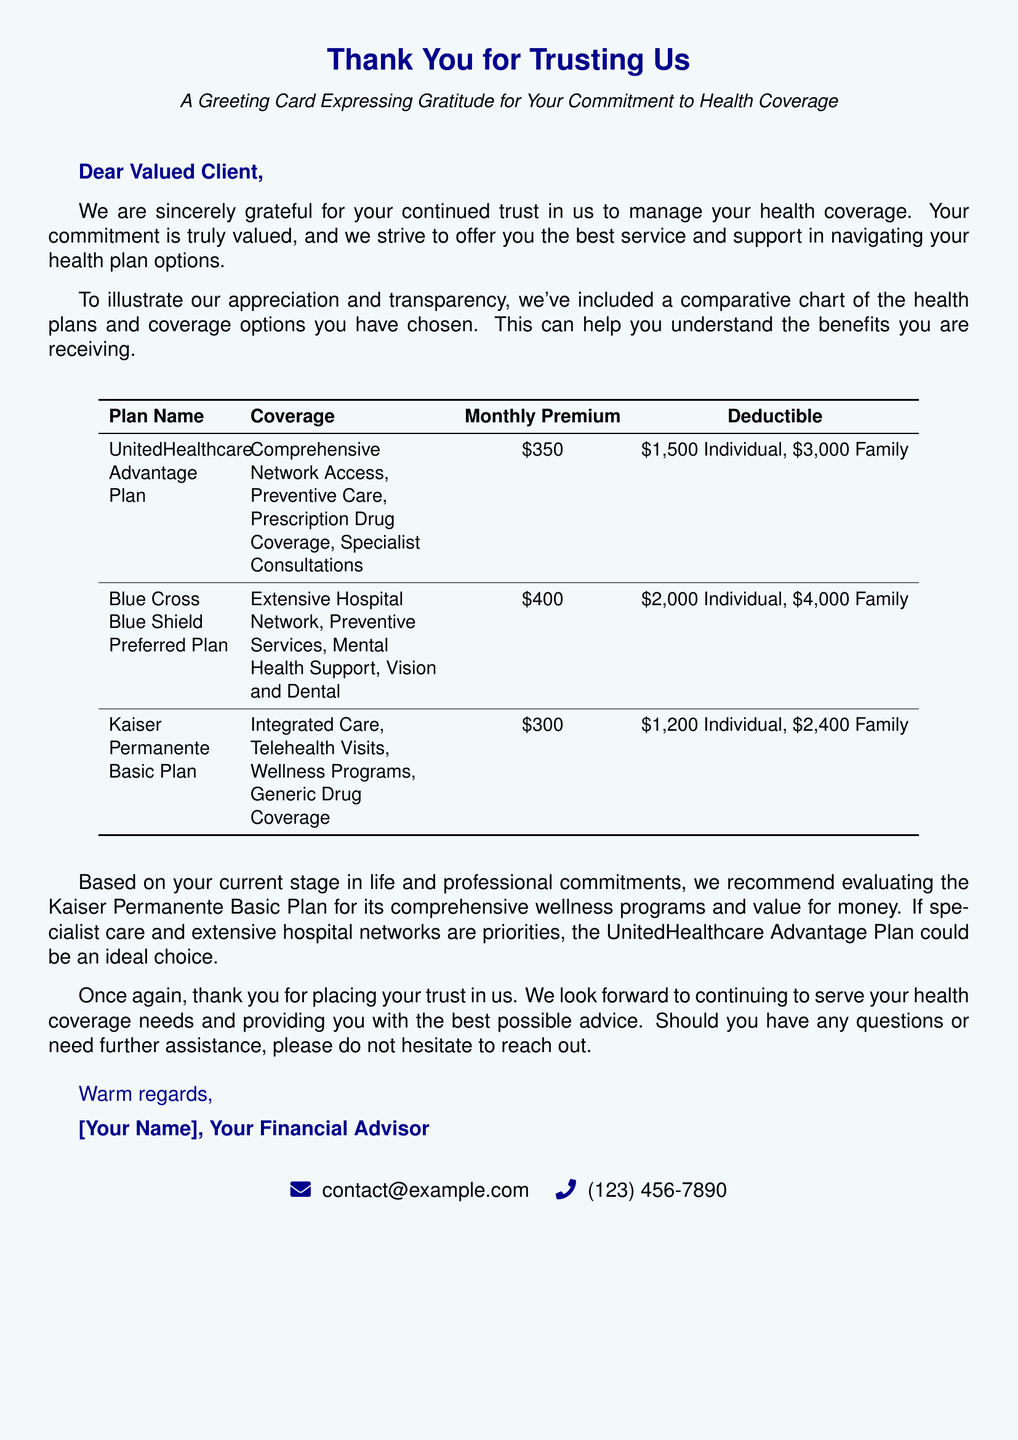What is the first plan listed? The first plan in the comparative chart is the UnitedHealthcare Advantage Plan.
Answer: UnitedHealthcare Advantage Plan What is the monthly premium for the Blue Cross Blue Shield Preferred Plan? The monthly premium for the Blue Cross Blue Shield Preferred Plan is noted in the chart.
Answer: $400 What is the deductible for a family under the Kaiser Permanente Basic Plan? The chart specifies the deductible amounts for the Kaiser Permanente Basic Plan.
Answer: $2,400 Family What recommendation is given based on the client's current stage in life? The card suggests evaluating the Kaiser Permanente Basic Plan based on certain factors mentioned in the text.
Answer: Kaiser Permanente Basic Plan What color is used for the greeting card background? The document specifies the color used for the greeting card's background.
Answer: Light blue How many health plans are compared in the chart? The chart includes a total of three health plans for comparison.
Answer: Three What is the closing phrase before the advisor's name? The closing phrase is a typical sign-off used in letters, which expresses gratitude.
Answer: Warm regards What type of support does the Blue Cross Blue Shield Preferred Plan include? It is mentioned in the chart specifically as part of its coverage options.
Answer: Mental Health Support 